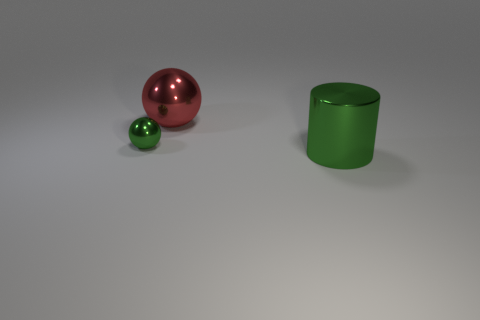There is a object behind the ball that is in front of the big red metal thing; is there a red ball that is to the right of it?
Provide a short and direct response. No. Is the number of tiny purple matte cylinders less than the number of big metallic things?
Your answer should be very brief. Yes. There is a thing right of the red metallic ball; is it the same shape as the red shiny object?
Provide a short and direct response. No. Are there any cylinders?
Your response must be concise. Yes. What is the color of the metallic object in front of the metallic object that is on the left side of the large thing on the left side of the large metal cylinder?
Provide a short and direct response. Green. Is the number of small green balls right of the green metallic cylinder the same as the number of balls that are to the right of the small metal ball?
Make the answer very short. No. There is a green thing that is the same size as the red metallic thing; what shape is it?
Give a very brief answer. Cylinder. Are there any other tiny balls that have the same color as the tiny ball?
Give a very brief answer. No. What is the shape of the big object that is behind the green cylinder?
Offer a very short reply. Sphere. The big metal cylinder is what color?
Ensure brevity in your answer.  Green. 